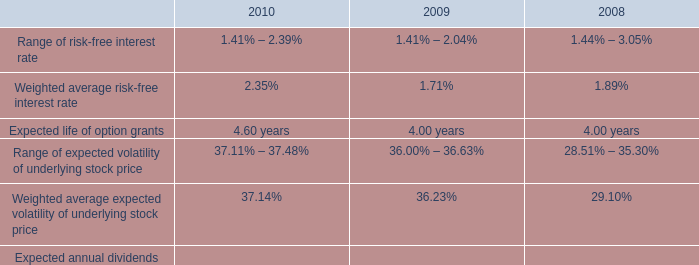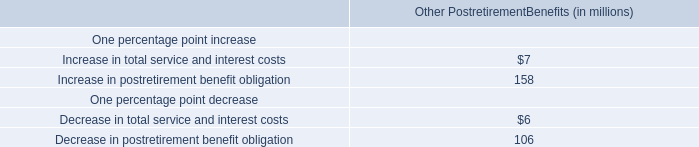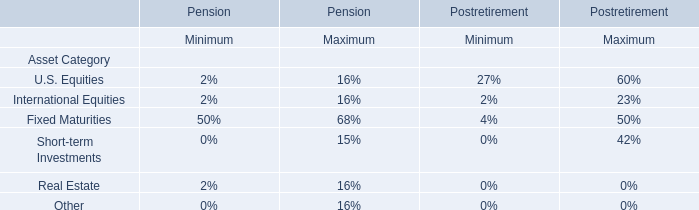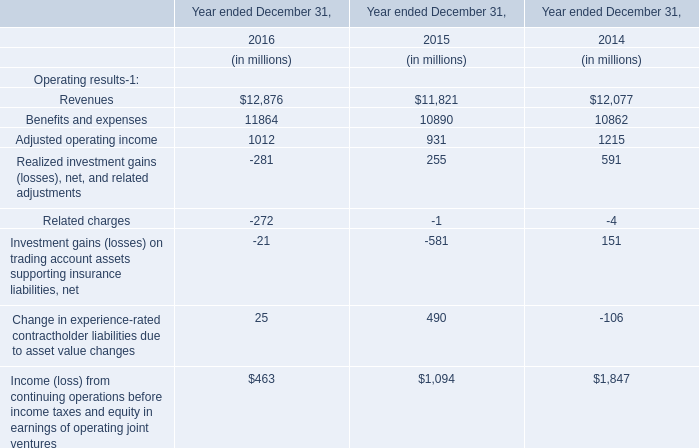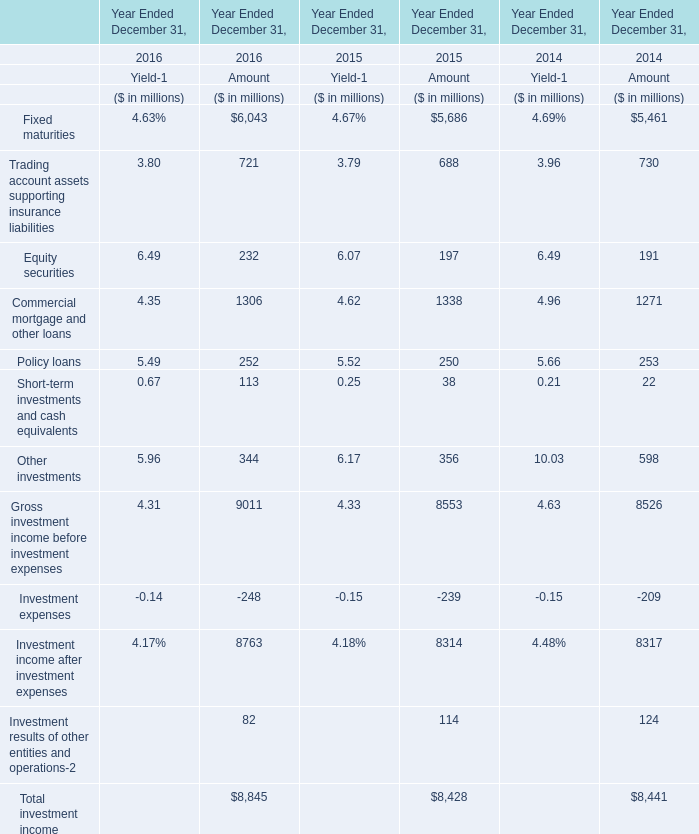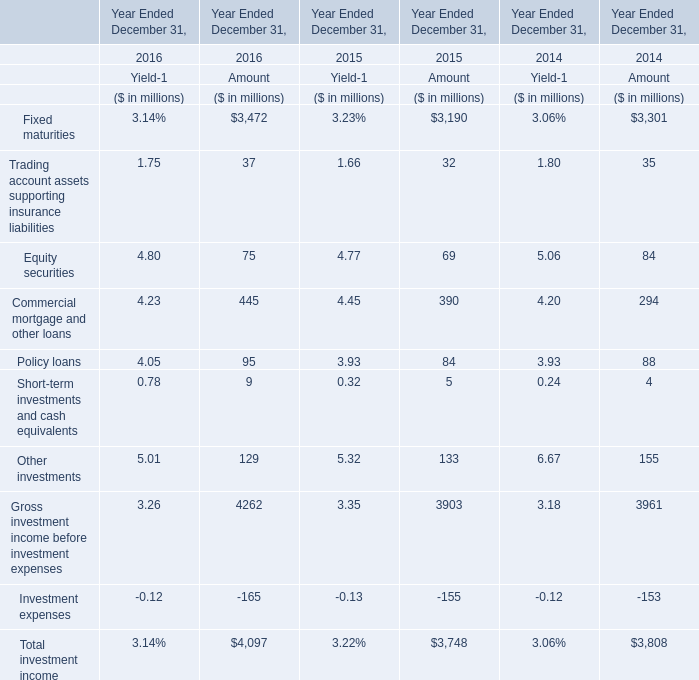what is the percentage change in the intrinsic value of stock options from 2007 to 2008? 
Computations: ((40.1 - 99.1) / 99.1)
Answer: -0.59536. 